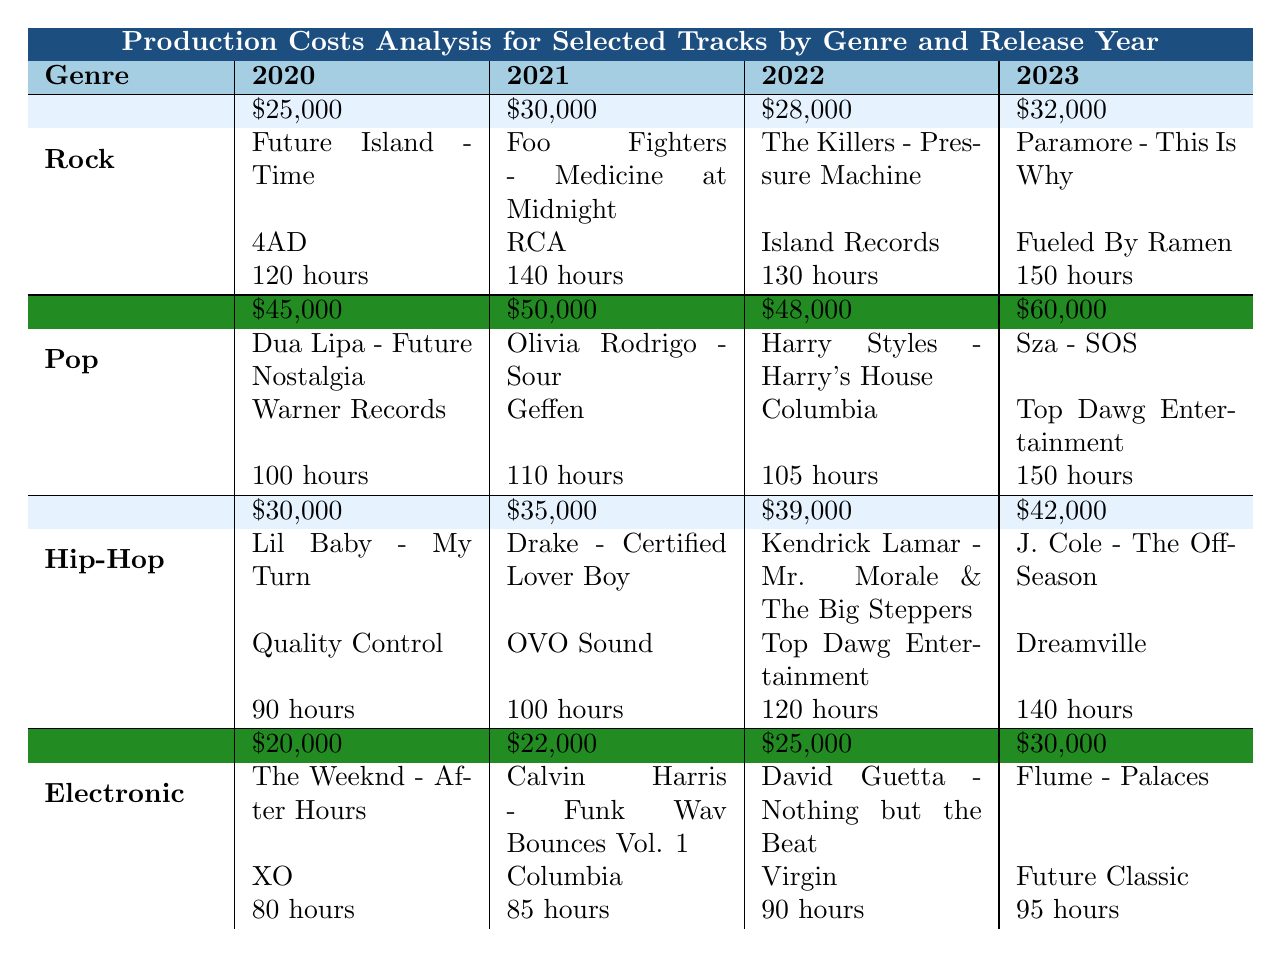What is the average production cost of Pop tracks in 2023? The average cost for Pop tracks in 2023 is listed in the table as $60,000.
Answer: $60,000 Which genre had the highest studio hours in 2022? In 2022, Pop had 105 studio hours, Rock had 130 hours, Hip-Hop had 120 hours, and Electronic had 90 hours. The highest number is 130 hours for Rock.
Answer: Rock What was the production cost difference between Hip-Hop tracks in 2020 and 2023? The Hip-Hop production cost in 2020 was $30,000 and in 2023 it was $42,000. The difference is $42,000 - $30,000 = $12,000.
Answer: $12,000 Is the top track for Electronic in 2022 “David Guetta - Nothing but the Beat”? The table indicates that the top track for Electronic in 2022 is “David Guetta - Nothing but the Beat,” so the statement is true.
Answer: Yes What is the average production cost across all genres in 2021? The average production costs for 2021 are $30,000 for Rock, $50,000 for Pop, $35,000 for Hip-Hop, and $22,000 for Electronic. Adding these gives $30,000 + $50,000 + $35,000 + $22,000 = $137,000. Dividing by 4 gives an average of $34,250.
Answer: $34,250 Which genre experiences the highest increase in average production cost from 2020 to 2023? Rock increased from $25,000 to $32,000 (+$7,000), Pop from $45,000 to $60,000 (+$15,000), Hip-Hop from $30,000 to $42,000 (+$12,000), and Electronic from $20,000 to $30,000 (+$10,000). Pop has the highest increase at $15,000.
Answer: Pop What is the top track for Rock in 2021? The top track for Rock in 2021 is listed in the table as “Foo Fighters - Medicine at Midnight.”
Answer: Foo Fighters - Medicine at Midnight Which genre had the lowest average production cost in 2020? The average costs in 2020 were Rock at $25,000, Pop at $45,000, Hip-Hop at $30,000, and Electronic at $20,000. The lowest is Electronic at $20,000.
Answer: Electronic How many studio hours were required for the top Pop track in 2022? The studio hours for the top Pop track in 2022, which is “Harry Styles - Harry's House,” is listed as 105 hours.
Answer: 105 hours What is the overall average cost of production for Rock tracks from 2020 to 2022? The costs for Rock from 2020 to 2022 are $25,000 (2020) + $30,000 (2021) + $28,000 (2022) = $83,000. Dividing by 3 gives an average of $27,666.67.
Answer: $27,666.67 